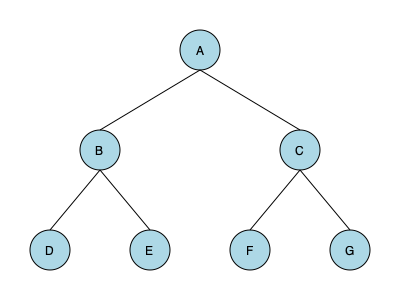Given the network topology diagram above, which configuration would be most efficient for minimizing network latency and maximizing data throughput? Assume all connections have equal bandwidth and each node represents a network switch. To determine the most efficient configuration for minimizing network latency and maximizing data throughput, we need to consider the following factors:

1. Hierarchy: The diagram shows a three-tier hierarchical topology.
2. Centralization: Node A acts as the central node.
3. Path length: The maximum number of hops between any two end nodes.
4. Redundancy: The presence of alternative paths.

Step-by-step analysis:
1. Hierarchy: The three-tier structure (A -> B/C -> D/E/F/G) allows for efficient traffic management and scalability.

2. Centralization: Node A serves as a central point, which can be beneficial for:
   a) Centralized management and control
   b) Efficient distribution of network-wide information

3. Path length:
   - Maximum path length = 3 hops (e.g., D to G: D -> B -> A -> C -> G)
   - Minimum path length = 2 hops (e.g., D to E: D -> B -> E)
   This relatively short path length helps minimize latency.

4. Redundancy:
   - There are no redundant paths in this topology.
   - While this reduces complexity, it also creates potential single points of failure.

5. Load distribution:
   - The topology evenly distributes end nodes (D, E, F, G) between the second-tier nodes (B and C).
   - This balance helps prevent bottlenecks and improves overall throughput.

Given these considerations, this topology is generally efficient for minimizing latency and maximizing throughput due to its hierarchical structure, short path lengths, and balanced distribution. However, it could be improved by adding redundant links between B and C, and possibly between some of the lower-tier nodes, to enhance fault tolerance and provide alternative paths for load balancing.

In proprietary systems, this type of topology is often used in enterprise networks, data centers, or campus networks where a balance between performance, scalability, and manageability is crucial.
Answer: Hierarchical star topology with potential for improvement through added redundancy 